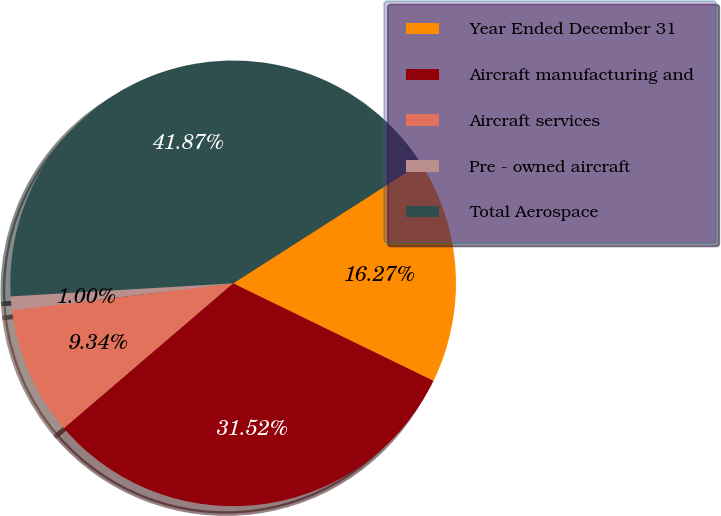Convert chart. <chart><loc_0><loc_0><loc_500><loc_500><pie_chart><fcel>Year Ended December 31<fcel>Aircraft manufacturing and<fcel>Aircraft services<fcel>Pre - owned aircraft<fcel>Total Aerospace<nl><fcel>16.27%<fcel>31.52%<fcel>9.34%<fcel>1.0%<fcel>41.87%<nl></chart> 